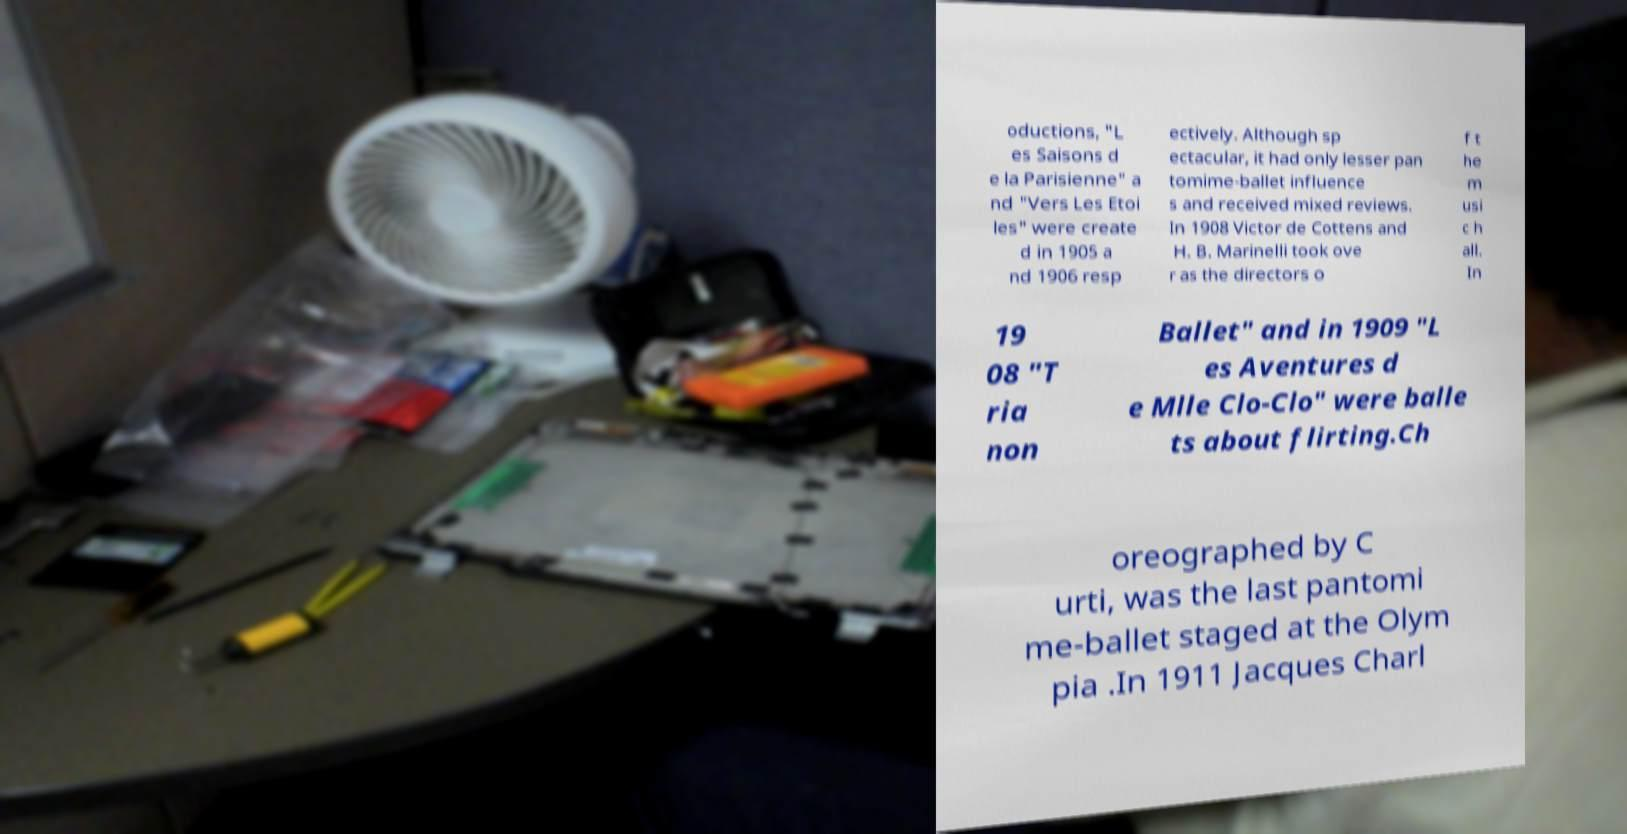Can you accurately transcribe the text from the provided image for me? oductions, "L es Saisons d e la Parisienne" a nd "Vers Les Etoi les" were create d in 1905 a nd 1906 resp ectively. Although sp ectacular, it had only lesser pan tomime-ballet influence s and received mixed reviews. In 1908 Victor de Cottens and H. B. Marinelli took ove r as the directors o f t he m usi c h all. In 19 08 "T ria non Ballet" and in 1909 "L es Aventures d e Mlle Clo-Clo" were balle ts about flirting.Ch oreographed by C urti, was the last pantomi me-ballet staged at the Olym pia .In 1911 Jacques Charl 